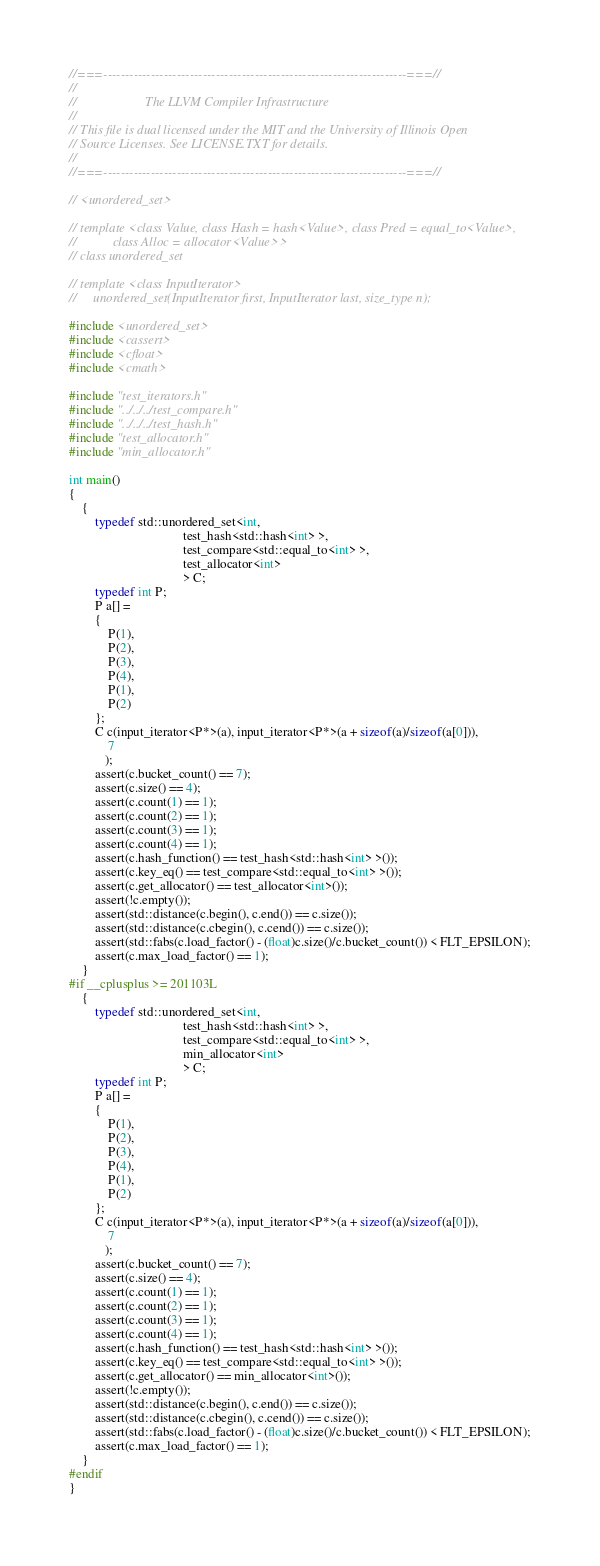<code> <loc_0><loc_0><loc_500><loc_500><_C++_>//===----------------------------------------------------------------------===//
//
//                     The LLVM Compiler Infrastructure
//
// This file is dual licensed under the MIT and the University of Illinois Open
// Source Licenses. See LICENSE.TXT for details.
//
//===----------------------------------------------------------------------===//

// <unordered_set>

// template <class Value, class Hash = hash<Value>, class Pred = equal_to<Value>,
//           class Alloc = allocator<Value>>
// class unordered_set

// template <class InputIterator>
//     unordered_set(InputIterator first, InputIterator last, size_type n);

#include <unordered_set>
#include <cassert>
#include <cfloat>
#include <cmath>

#include "test_iterators.h"
#include "../../../test_compare.h"
#include "../../../test_hash.h"
#include "test_allocator.h"
#include "min_allocator.h"

int main()
{
    {
        typedef std::unordered_set<int,
                                   test_hash<std::hash<int> >,
                                   test_compare<std::equal_to<int> >,
                                   test_allocator<int>
                                   > C;
        typedef int P;
        P a[] =
        {
            P(1),
            P(2),
            P(3),
            P(4),
            P(1),
            P(2)
        };
        C c(input_iterator<P*>(a), input_iterator<P*>(a + sizeof(a)/sizeof(a[0])),
            7
           );
        assert(c.bucket_count() == 7);
        assert(c.size() == 4);
        assert(c.count(1) == 1);
        assert(c.count(2) == 1);
        assert(c.count(3) == 1);
        assert(c.count(4) == 1);
        assert(c.hash_function() == test_hash<std::hash<int> >());
        assert(c.key_eq() == test_compare<std::equal_to<int> >());
        assert(c.get_allocator() == test_allocator<int>());
        assert(!c.empty());
        assert(std::distance(c.begin(), c.end()) == c.size());
        assert(std::distance(c.cbegin(), c.cend()) == c.size());
        assert(std::fabs(c.load_factor() - (float)c.size()/c.bucket_count()) < FLT_EPSILON);
        assert(c.max_load_factor() == 1);
    }
#if __cplusplus >= 201103L
    {
        typedef std::unordered_set<int,
                                   test_hash<std::hash<int> >,
                                   test_compare<std::equal_to<int> >,
                                   min_allocator<int>
                                   > C;
        typedef int P;
        P a[] =
        {
            P(1),
            P(2),
            P(3),
            P(4),
            P(1),
            P(2)
        };
        C c(input_iterator<P*>(a), input_iterator<P*>(a + sizeof(a)/sizeof(a[0])),
            7
           );
        assert(c.bucket_count() == 7);
        assert(c.size() == 4);
        assert(c.count(1) == 1);
        assert(c.count(2) == 1);
        assert(c.count(3) == 1);
        assert(c.count(4) == 1);
        assert(c.hash_function() == test_hash<std::hash<int> >());
        assert(c.key_eq() == test_compare<std::equal_to<int> >());
        assert(c.get_allocator() == min_allocator<int>());
        assert(!c.empty());
        assert(std::distance(c.begin(), c.end()) == c.size());
        assert(std::distance(c.cbegin(), c.cend()) == c.size());
        assert(std::fabs(c.load_factor() - (float)c.size()/c.bucket_count()) < FLT_EPSILON);
        assert(c.max_load_factor() == 1);
    }
#endif
}
</code> 